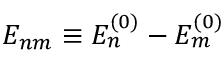<formula> <loc_0><loc_0><loc_500><loc_500>E _ { n m } \equiv E _ { n } ^ { ( 0 ) } - E _ { m } ^ { ( 0 ) }</formula> 